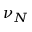<formula> <loc_0><loc_0><loc_500><loc_500>\nu _ { N }</formula> 